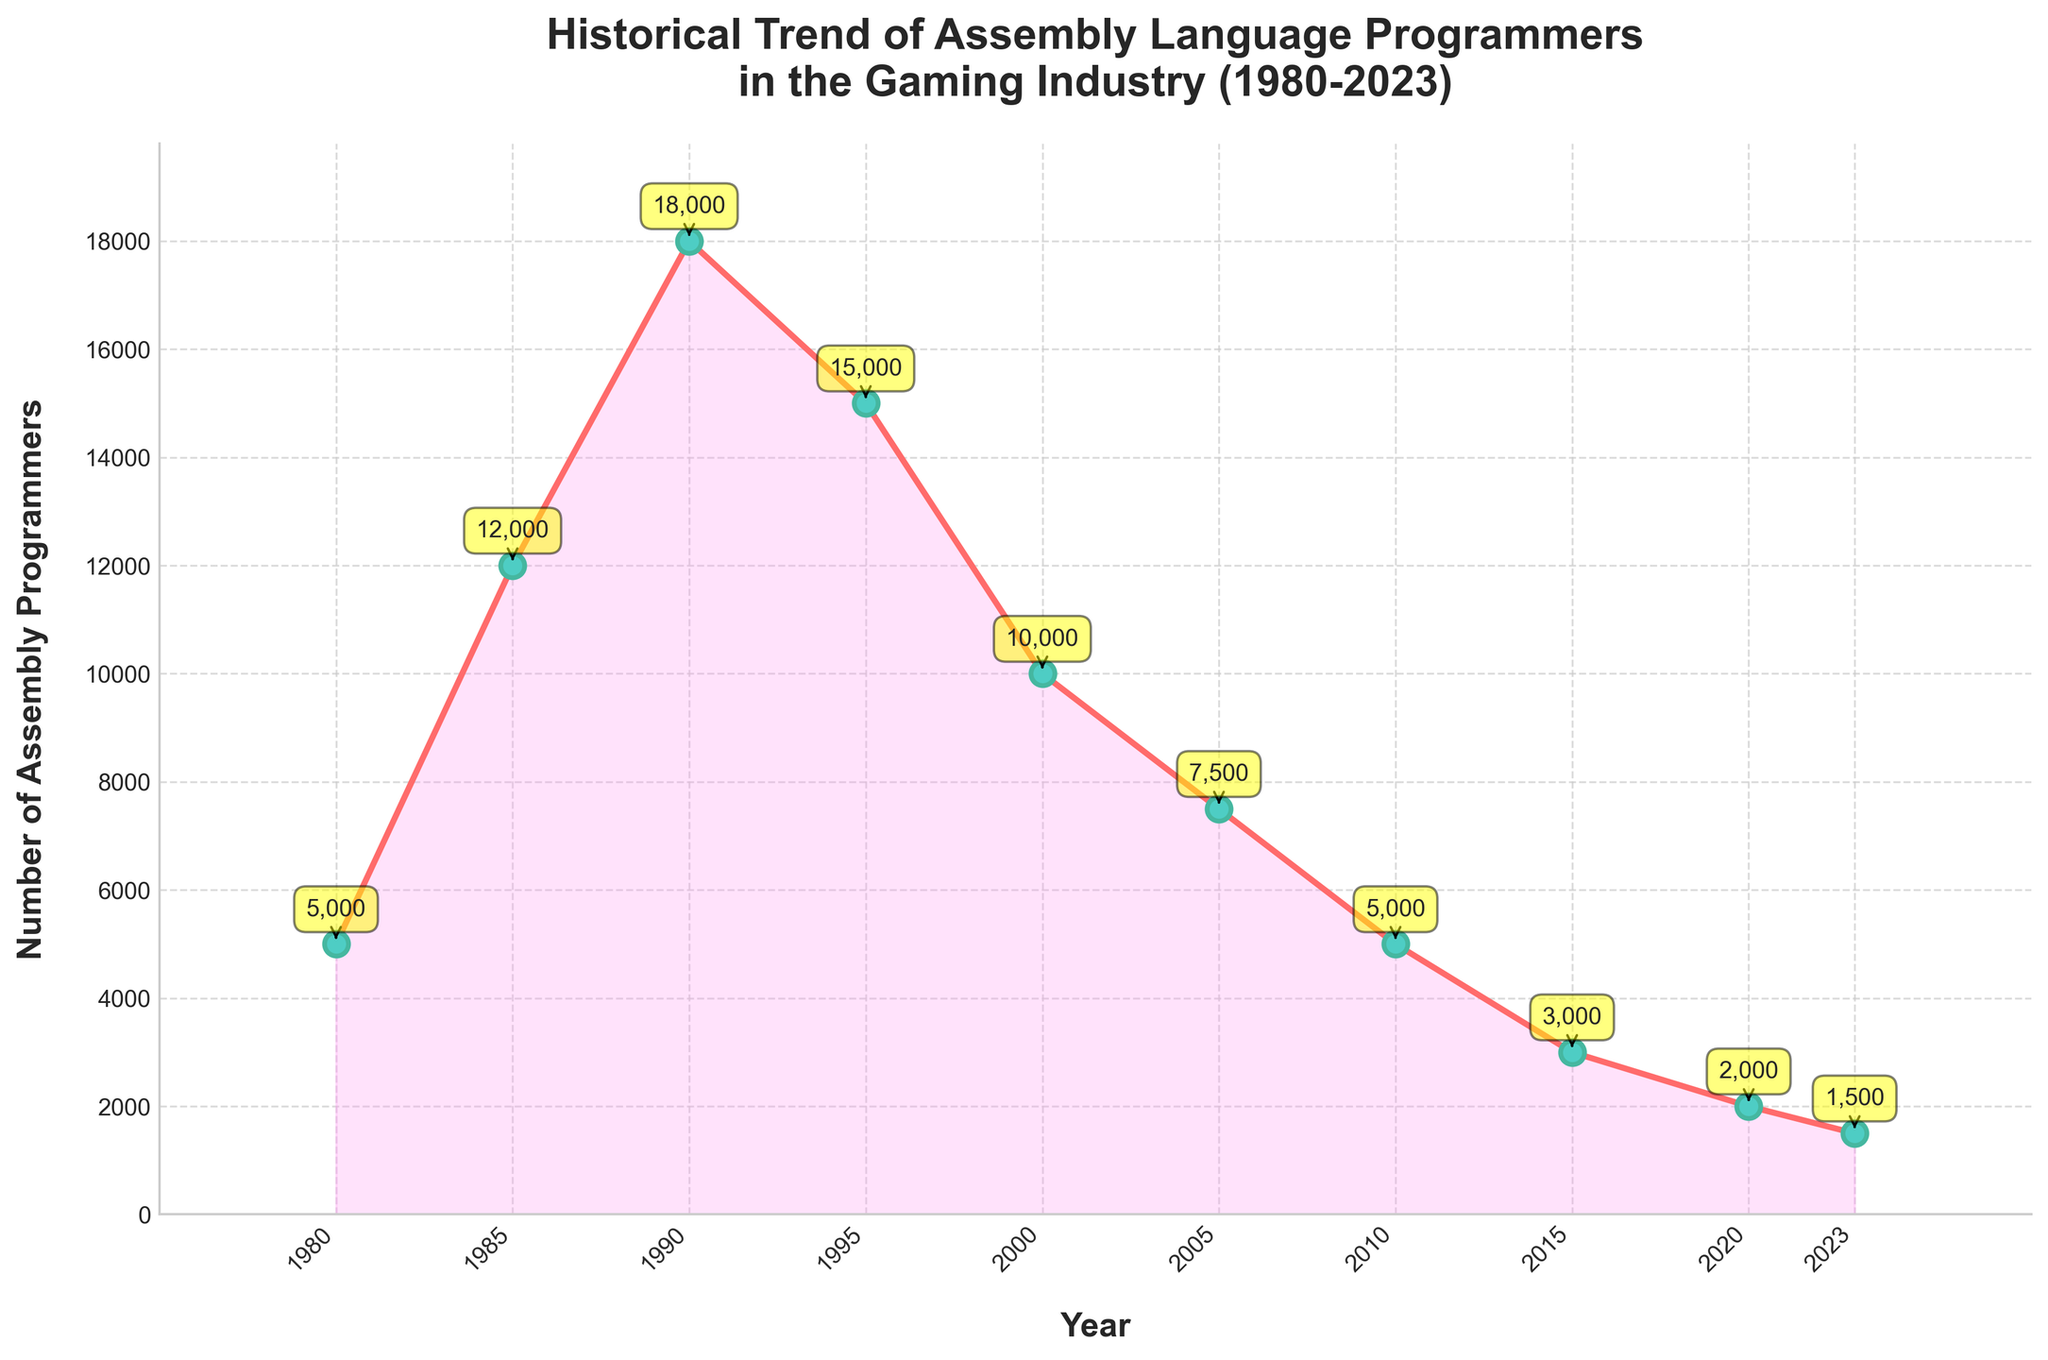What is the trend of the number of assembly language programmers from 1980 to 2023? The general trend shows an increase in the number of programmers from 1980 to 1990, followed by a decline from 1990 onwards.
Answer: Increasing until 1990, then decreasing Between which years did the number of assembly language programmers peak? By observing the highest point on the graph, it is clear that the peak occurs in 1990.
Answer: 1990 How does the number of assembly language programmers in 2023 compare to the number in 1980? The number of programmers in 2023 (1500) is significantly lower than in 1980 (5000).
Answer: Lower What is the rate of decline in the number of programmers from 1990 to 2005? The number of programmers dropped from 18000 in 1990 to 7500 in 2005. The rate of decline is (18000 - 7500) / 15 years.
Answer: 700 per year How does the number of programmers in 1985 compare to the number in 2020? In 1985, there were 12000 programmers, whereas in 2020, there were only 2000, indicating a significant decrease.
Answer: Higher in 1985 By how much did the number of assembly language programmers decrease from 1995 to 2000? The number of programmers in 1995 was 15000, and in 2000 it was 10000. The decrease is 15000 - 10000.
Answer: 5000 What is the difference in the number of programmers between the peak year and the lowest year? The peak year is 1990 with 18000 programmers, and the lowest year is 2023 with 1500. The difference is 18000 - 1500.
Answer: 16500 From 2010 to 2023, how has the number of assembly language programmers changed? In 2010, there were 5000 programmers. By 2023, this number had decreased to 1500. The decrease is 5000 - 1500.
Answer: Decreased by 3500 What's the average number of assembly language programmers from 1980 to 2023? Sum of the number of programmers (5000 + 12000 + 18000 + 15000 + 10000 + 7500 + 5000 + 3000 + 2000 + 1500) is 79000. The number of years is 10. So, the average is 79000 / 10.
Answer: 7900 Identify the period with the most rapid decline in the number of assembly language programmers. The number of programmers declined most rapidly from 1990 to 2000. The year-by-year decline from 1990 to 2000 was 8000, compared to other periods.
Answer: 1990 to 2000 